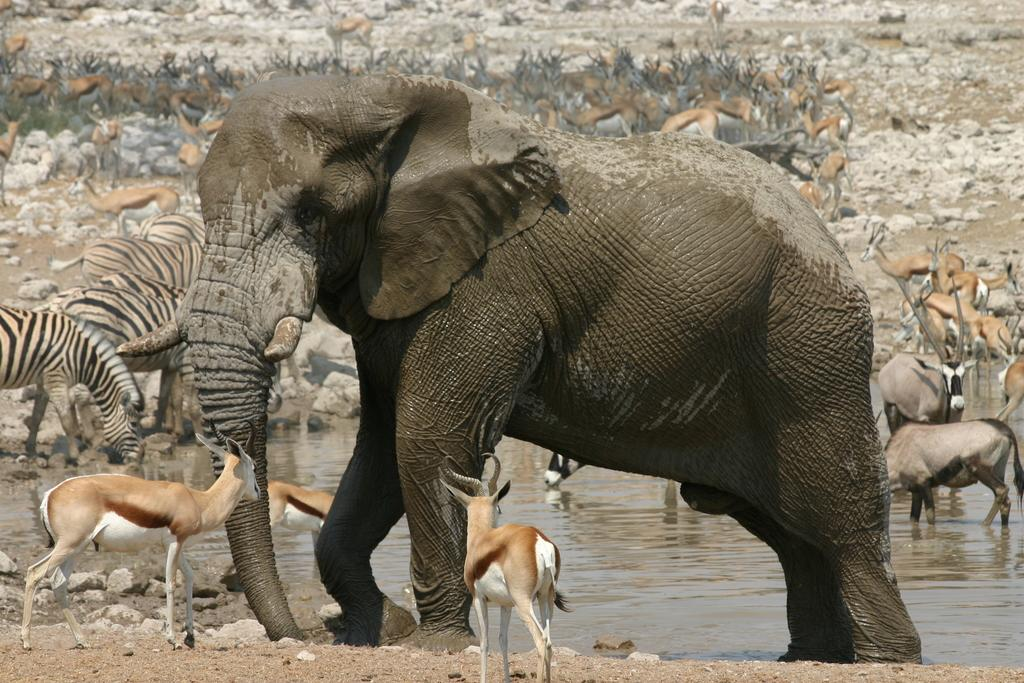What type of animal is the main subject of the image? There is an elephant in the image. Are there any other animals present in the image? Yes, there are zebras in the image. Where are the animals located in the image? Some animals are on the water, while others are on the ground in the image. What type of paste can be seen on the elephant's trunk in the image? There is no paste present on the elephant's trunk in the image. What scent is emitted by the sheep in the image? There are no sheep present in the image. 